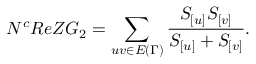<formula> <loc_0><loc_0><loc_500><loc_500>N ^ { c } R e Z G _ { 2 } = \sum _ { u v \in E { ( \Gamma ) } } \frac { S _ { [ u ] } S _ { [ v ] } } { S _ { [ u ] } + S _ { [ v ] } } .</formula> 